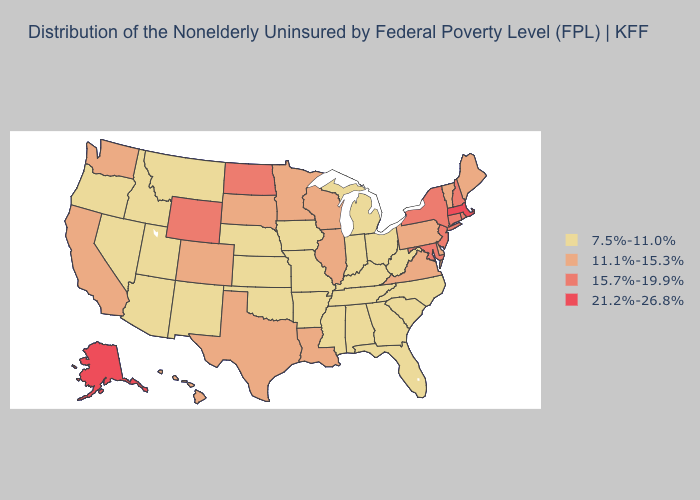What is the lowest value in states that border Michigan?
Give a very brief answer. 7.5%-11.0%. Which states have the lowest value in the USA?
Concise answer only. Alabama, Arizona, Arkansas, Florida, Georgia, Idaho, Indiana, Iowa, Kansas, Kentucky, Michigan, Mississippi, Missouri, Montana, Nebraska, Nevada, New Mexico, North Carolina, Ohio, Oklahoma, Oregon, South Carolina, Tennessee, Utah, West Virginia. What is the value of Indiana?
Keep it brief. 7.5%-11.0%. Name the states that have a value in the range 7.5%-11.0%?
Concise answer only. Alabama, Arizona, Arkansas, Florida, Georgia, Idaho, Indiana, Iowa, Kansas, Kentucky, Michigan, Mississippi, Missouri, Montana, Nebraska, Nevada, New Mexico, North Carolina, Ohio, Oklahoma, Oregon, South Carolina, Tennessee, Utah, West Virginia. Name the states that have a value in the range 7.5%-11.0%?
Short answer required. Alabama, Arizona, Arkansas, Florida, Georgia, Idaho, Indiana, Iowa, Kansas, Kentucky, Michigan, Mississippi, Missouri, Montana, Nebraska, Nevada, New Mexico, North Carolina, Ohio, Oklahoma, Oregon, South Carolina, Tennessee, Utah, West Virginia. Does Alaska have the highest value in the West?
Be succinct. Yes. Does Indiana have the highest value in the MidWest?
Short answer required. No. Name the states that have a value in the range 21.2%-26.8%?
Give a very brief answer. Alaska, Massachusetts. Which states hav the highest value in the South?
Give a very brief answer. Maryland. Does Louisiana have a lower value than Illinois?
Short answer required. No. Among the states that border Arkansas , which have the lowest value?
Be succinct. Mississippi, Missouri, Oklahoma, Tennessee. Does Massachusetts have the highest value in the Northeast?
Short answer required. Yes. What is the lowest value in the Northeast?
Be succinct. 11.1%-15.3%. Which states have the lowest value in the MidWest?
Concise answer only. Indiana, Iowa, Kansas, Michigan, Missouri, Nebraska, Ohio. Name the states that have a value in the range 15.7%-19.9%?
Keep it brief. Connecticut, Maryland, New Hampshire, New Jersey, New York, North Dakota, Rhode Island, Wyoming. 